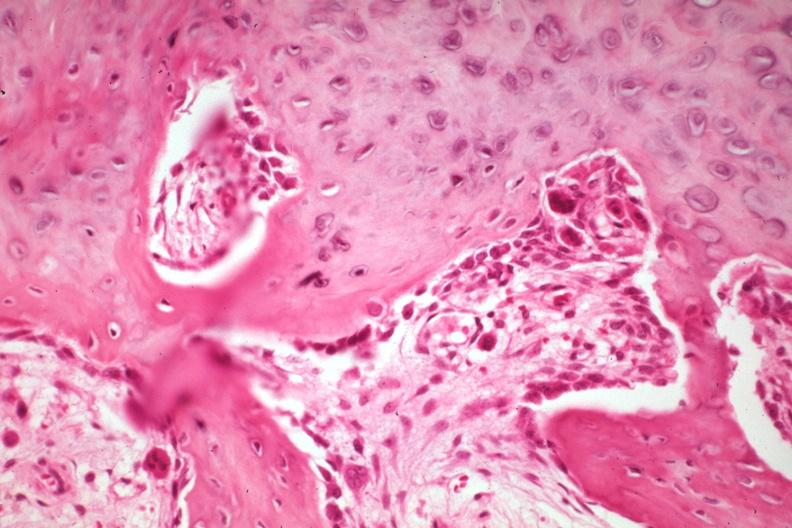s joints present?
Answer the question using a single word or phrase. Yes 